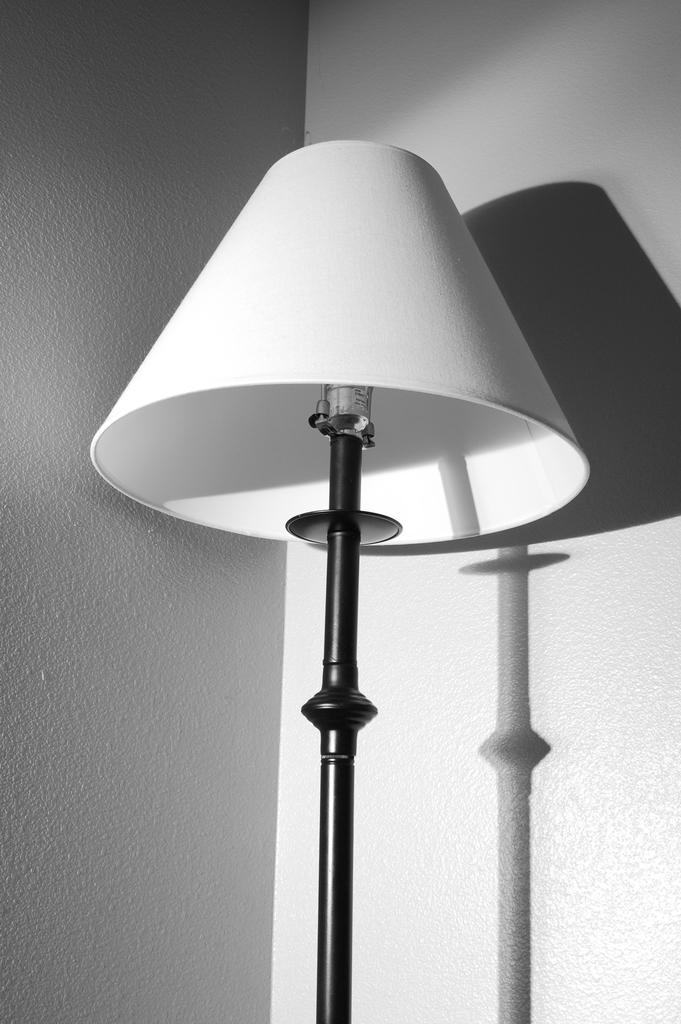How would you summarize this image in a sentence or two? Here we can see a black and white picture. There is a lamp. In the background we can see shadow of a lamp on the wall. 